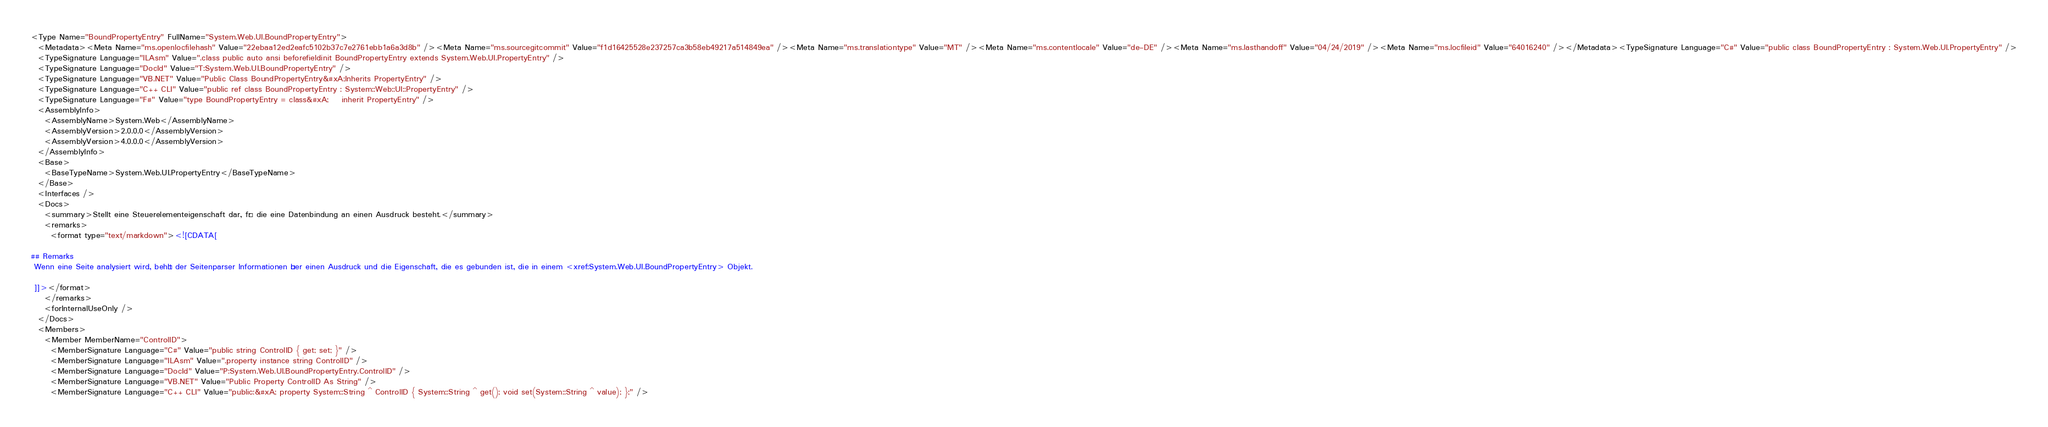Convert code to text. <code><loc_0><loc_0><loc_500><loc_500><_XML_><Type Name="BoundPropertyEntry" FullName="System.Web.UI.BoundPropertyEntry">
  <Metadata><Meta Name="ms.openlocfilehash" Value="22ebaa12ed2eafc5102b37c7e2761ebb1a6a3d8b" /><Meta Name="ms.sourcegitcommit" Value="f1d16425528e237257ca3b58eb49217a514849ea" /><Meta Name="ms.translationtype" Value="MT" /><Meta Name="ms.contentlocale" Value="de-DE" /><Meta Name="ms.lasthandoff" Value="04/24/2019" /><Meta Name="ms.locfileid" Value="64016240" /></Metadata><TypeSignature Language="C#" Value="public class BoundPropertyEntry : System.Web.UI.PropertyEntry" />
  <TypeSignature Language="ILAsm" Value=".class public auto ansi beforefieldinit BoundPropertyEntry extends System.Web.UI.PropertyEntry" />
  <TypeSignature Language="DocId" Value="T:System.Web.UI.BoundPropertyEntry" />
  <TypeSignature Language="VB.NET" Value="Public Class BoundPropertyEntry&#xA;Inherits PropertyEntry" />
  <TypeSignature Language="C++ CLI" Value="public ref class BoundPropertyEntry : System::Web::UI::PropertyEntry" />
  <TypeSignature Language="F#" Value="type BoundPropertyEntry = class&#xA;    inherit PropertyEntry" />
  <AssemblyInfo>
    <AssemblyName>System.Web</AssemblyName>
    <AssemblyVersion>2.0.0.0</AssemblyVersion>
    <AssemblyVersion>4.0.0.0</AssemblyVersion>
  </AssemblyInfo>
  <Base>
    <BaseTypeName>System.Web.UI.PropertyEntry</BaseTypeName>
  </Base>
  <Interfaces />
  <Docs>
    <summary>Stellt eine Steuerelementeigenschaft dar, für die eine Datenbindung an einen Ausdruck besteht.</summary>
    <remarks>
      <format type="text/markdown"><![CDATA[  
  
## Remarks  
 Wenn eine Seite analysiert wird, behält der Seitenparser Informationen über einen Ausdruck und die Eigenschaft, die es gebunden ist, die in einem <xref:System.Web.UI.BoundPropertyEntry> Objekt.  
  
 ]]></format>
    </remarks>
    <forInternalUseOnly />
  </Docs>
  <Members>
    <Member MemberName="ControlID">
      <MemberSignature Language="C#" Value="public string ControlID { get; set; }" />
      <MemberSignature Language="ILAsm" Value=".property instance string ControlID" />
      <MemberSignature Language="DocId" Value="P:System.Web.UI.BoundPropertyEntry.ControlID" />
      <MemberSignature Language="VB.NET" Value="Public Property ControlID As String" />
      <MemberSignature Language="C++ CLI" Value="public:&#xA; property System::String ^ ControlID { System::String ^ get(); void set(System::String ^ value); };" /></code> 